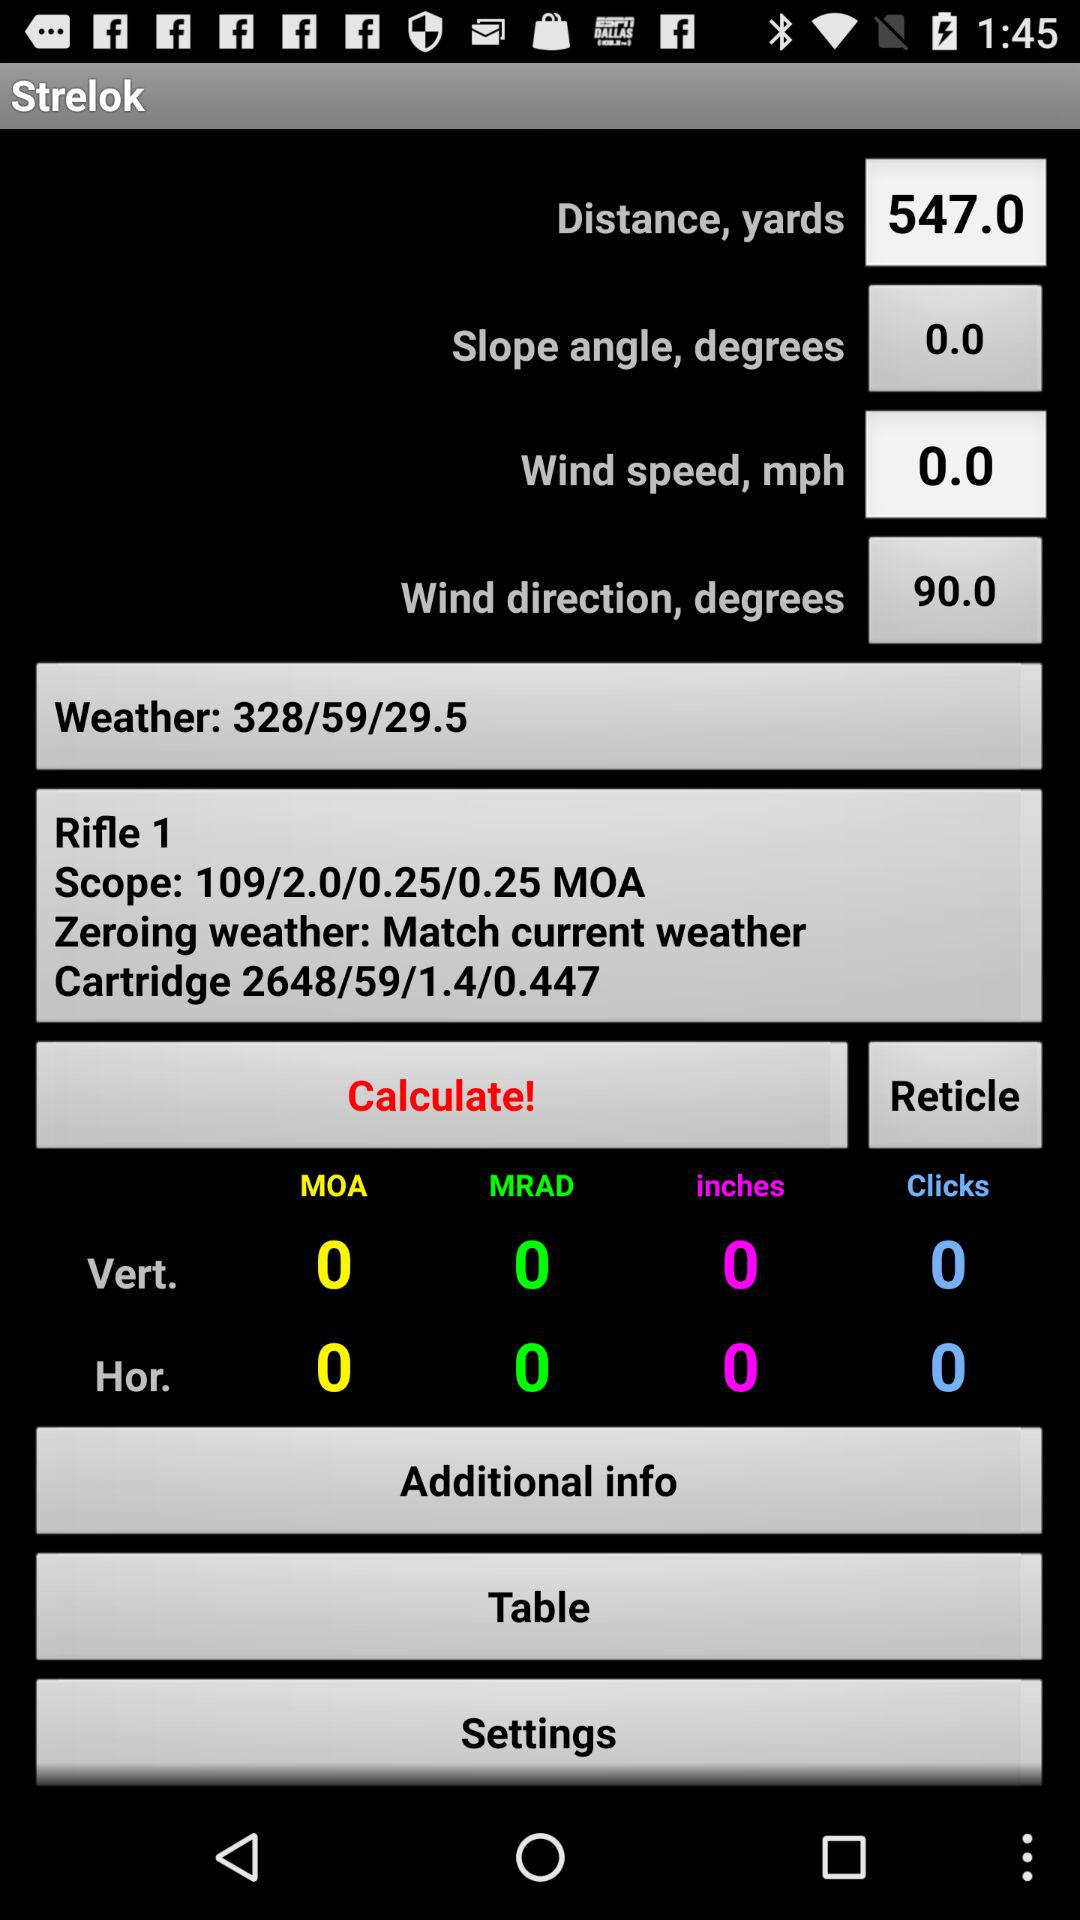What is the weather? The weather is 328/59/29.5. 